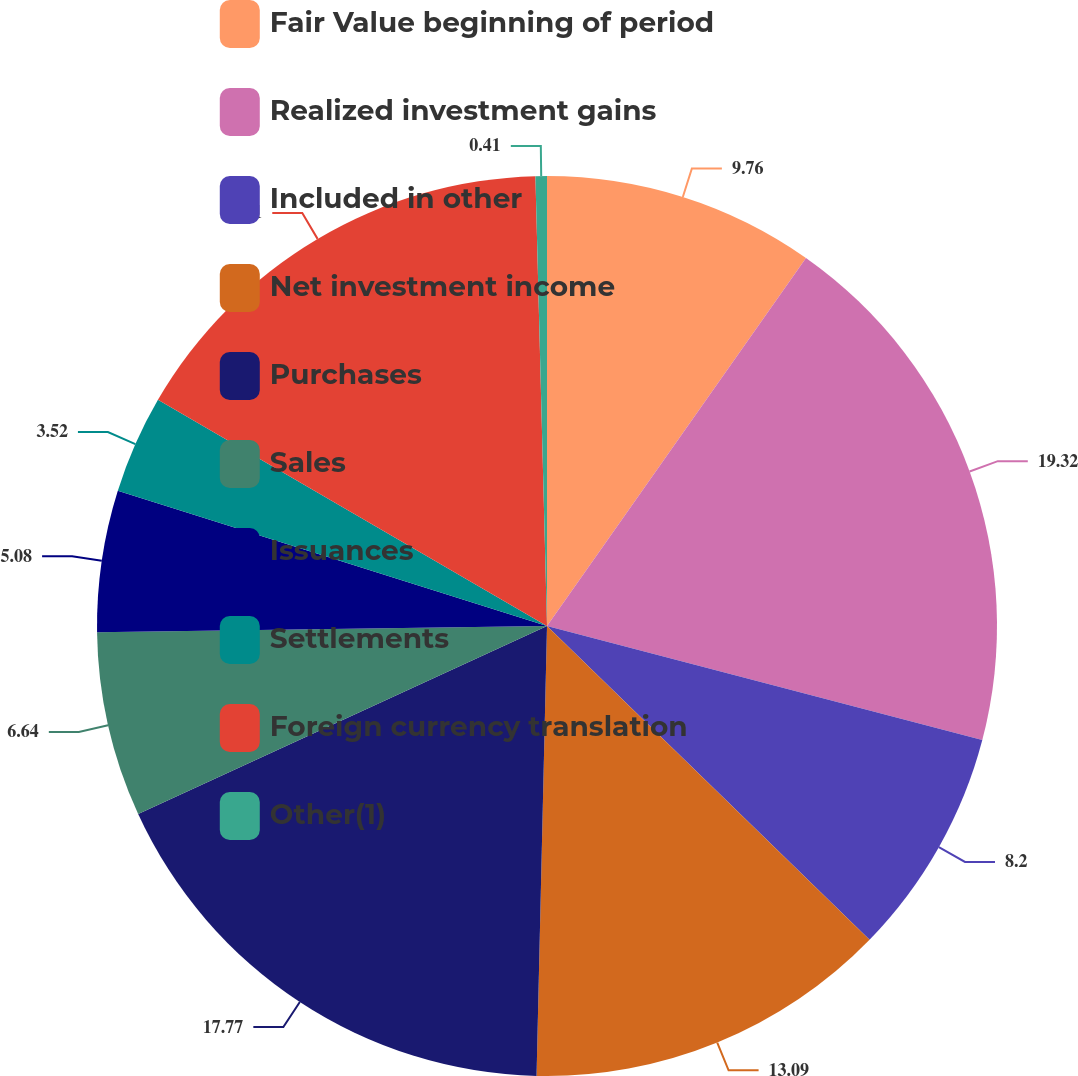<chart> <loc_0><loc_0><loc_500><loc_500><pie_chart><fcel>Fair Value beginning of period<fcel>Realized investment gains<fcel>Included in other<fcel>Net investment income<fcel>Purchases<fcel>Sales<fcel>Issuances<fcel>Settlements<fcel>Foreign currency translation<fcel>Other(1)<nl><fcel>9.76%<fcel>19.32%<fcel>8.2%<fcel>13.09%<fcel>17.77%<fcel>6.64%<fcel>5.08%<fcel>3.52%<fcel>16.21%<fcel>0.41%<nl></chart> 